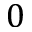<formula> <loc_0><loc_0><loc_500><loc_500>0</formula> 